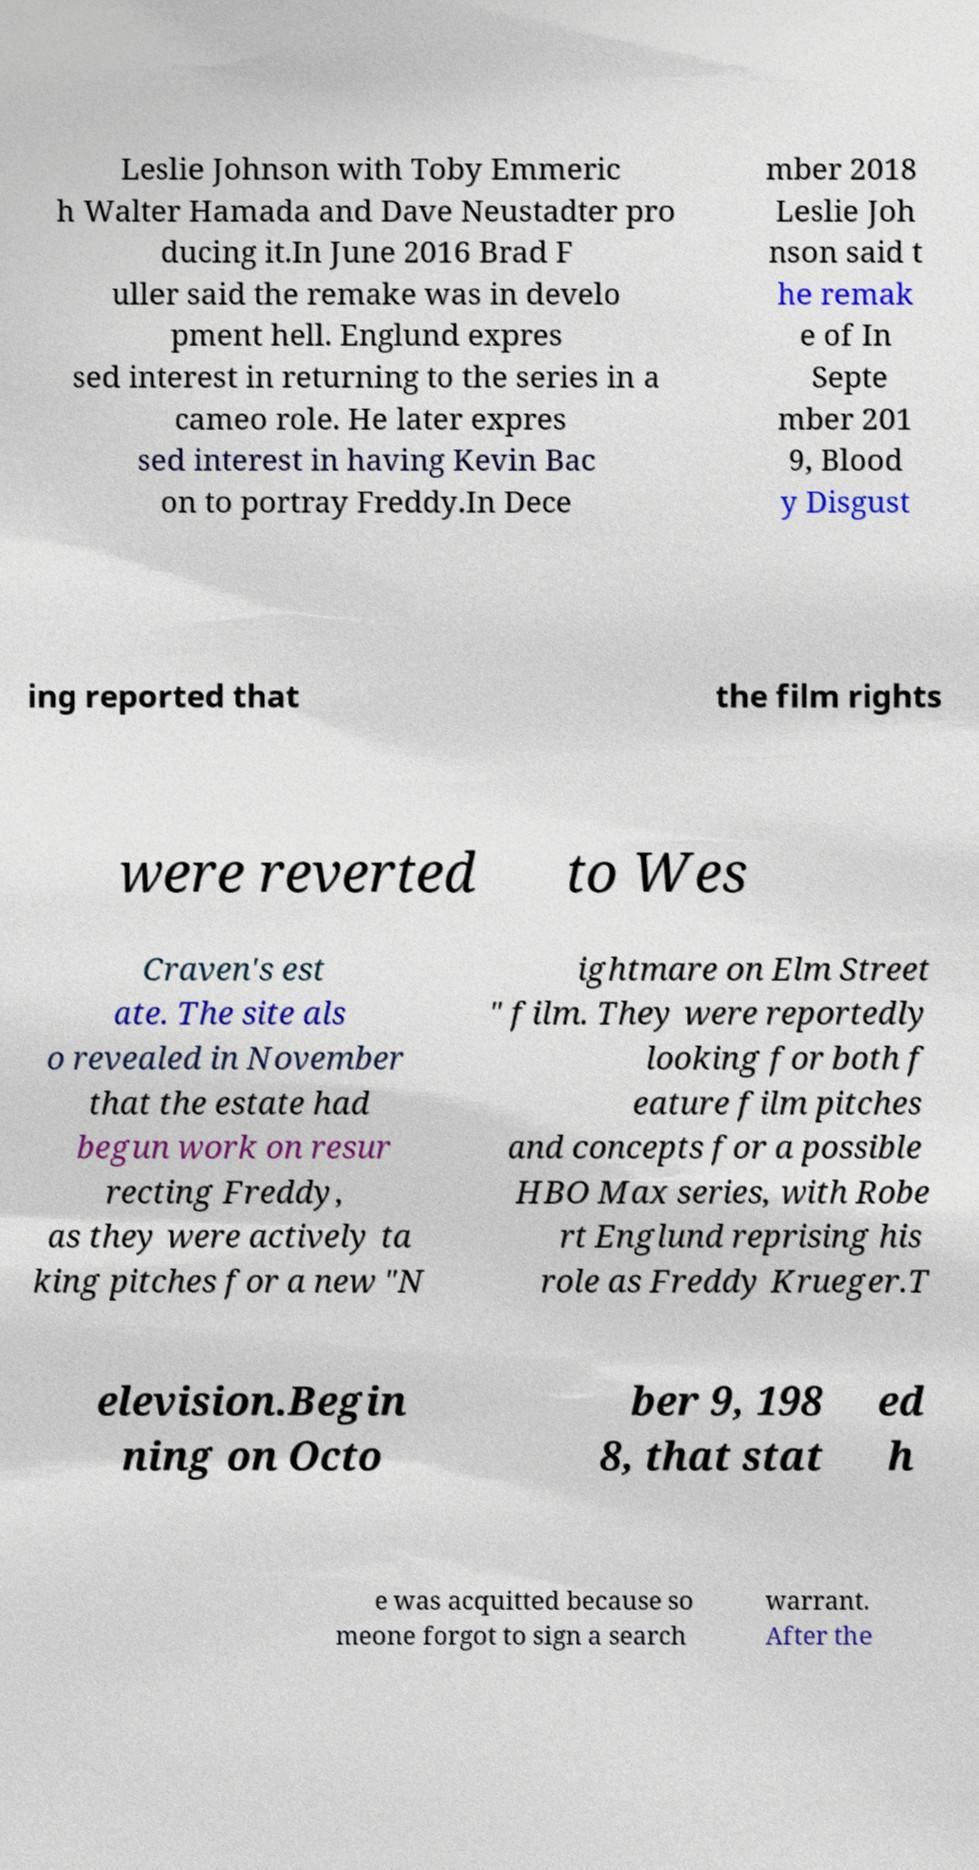For documentation purposes, I need the text within this image transcribed. Could you provide that? Leslie Johnson with Toby Emmeric h Walter Hamada and Dave Neustadter pro ducing it.In June 2016 Brad F uller said the remake was in develo pment hell. Englund expres sed interest in returning to the series in a cameo role. He later expres sed interest in having Kevin Bac on to portray Freddy.In Dece mber 2018 Leslie Joh nson said t he remak e of In Septe mber 201 9, Blood y Disgust ing reported that the film rights were reverted to Wes Craven's est ate. The site als o revealed in November that the estate had begun work on resur recting Freddy, as they were actively ta king pitches for a new "N ightmare on Elm Street " film. They were reportedly looking for both f eature film pitches and concepts for a possible HBO Max series, with Robe rt Englund reprising his role as Freddy Krueger.T elevision.Begin ning on Octo ber 9, 198 8, that stat ed h e was acquitted because so meone forgot to sign a search warrant. After the 